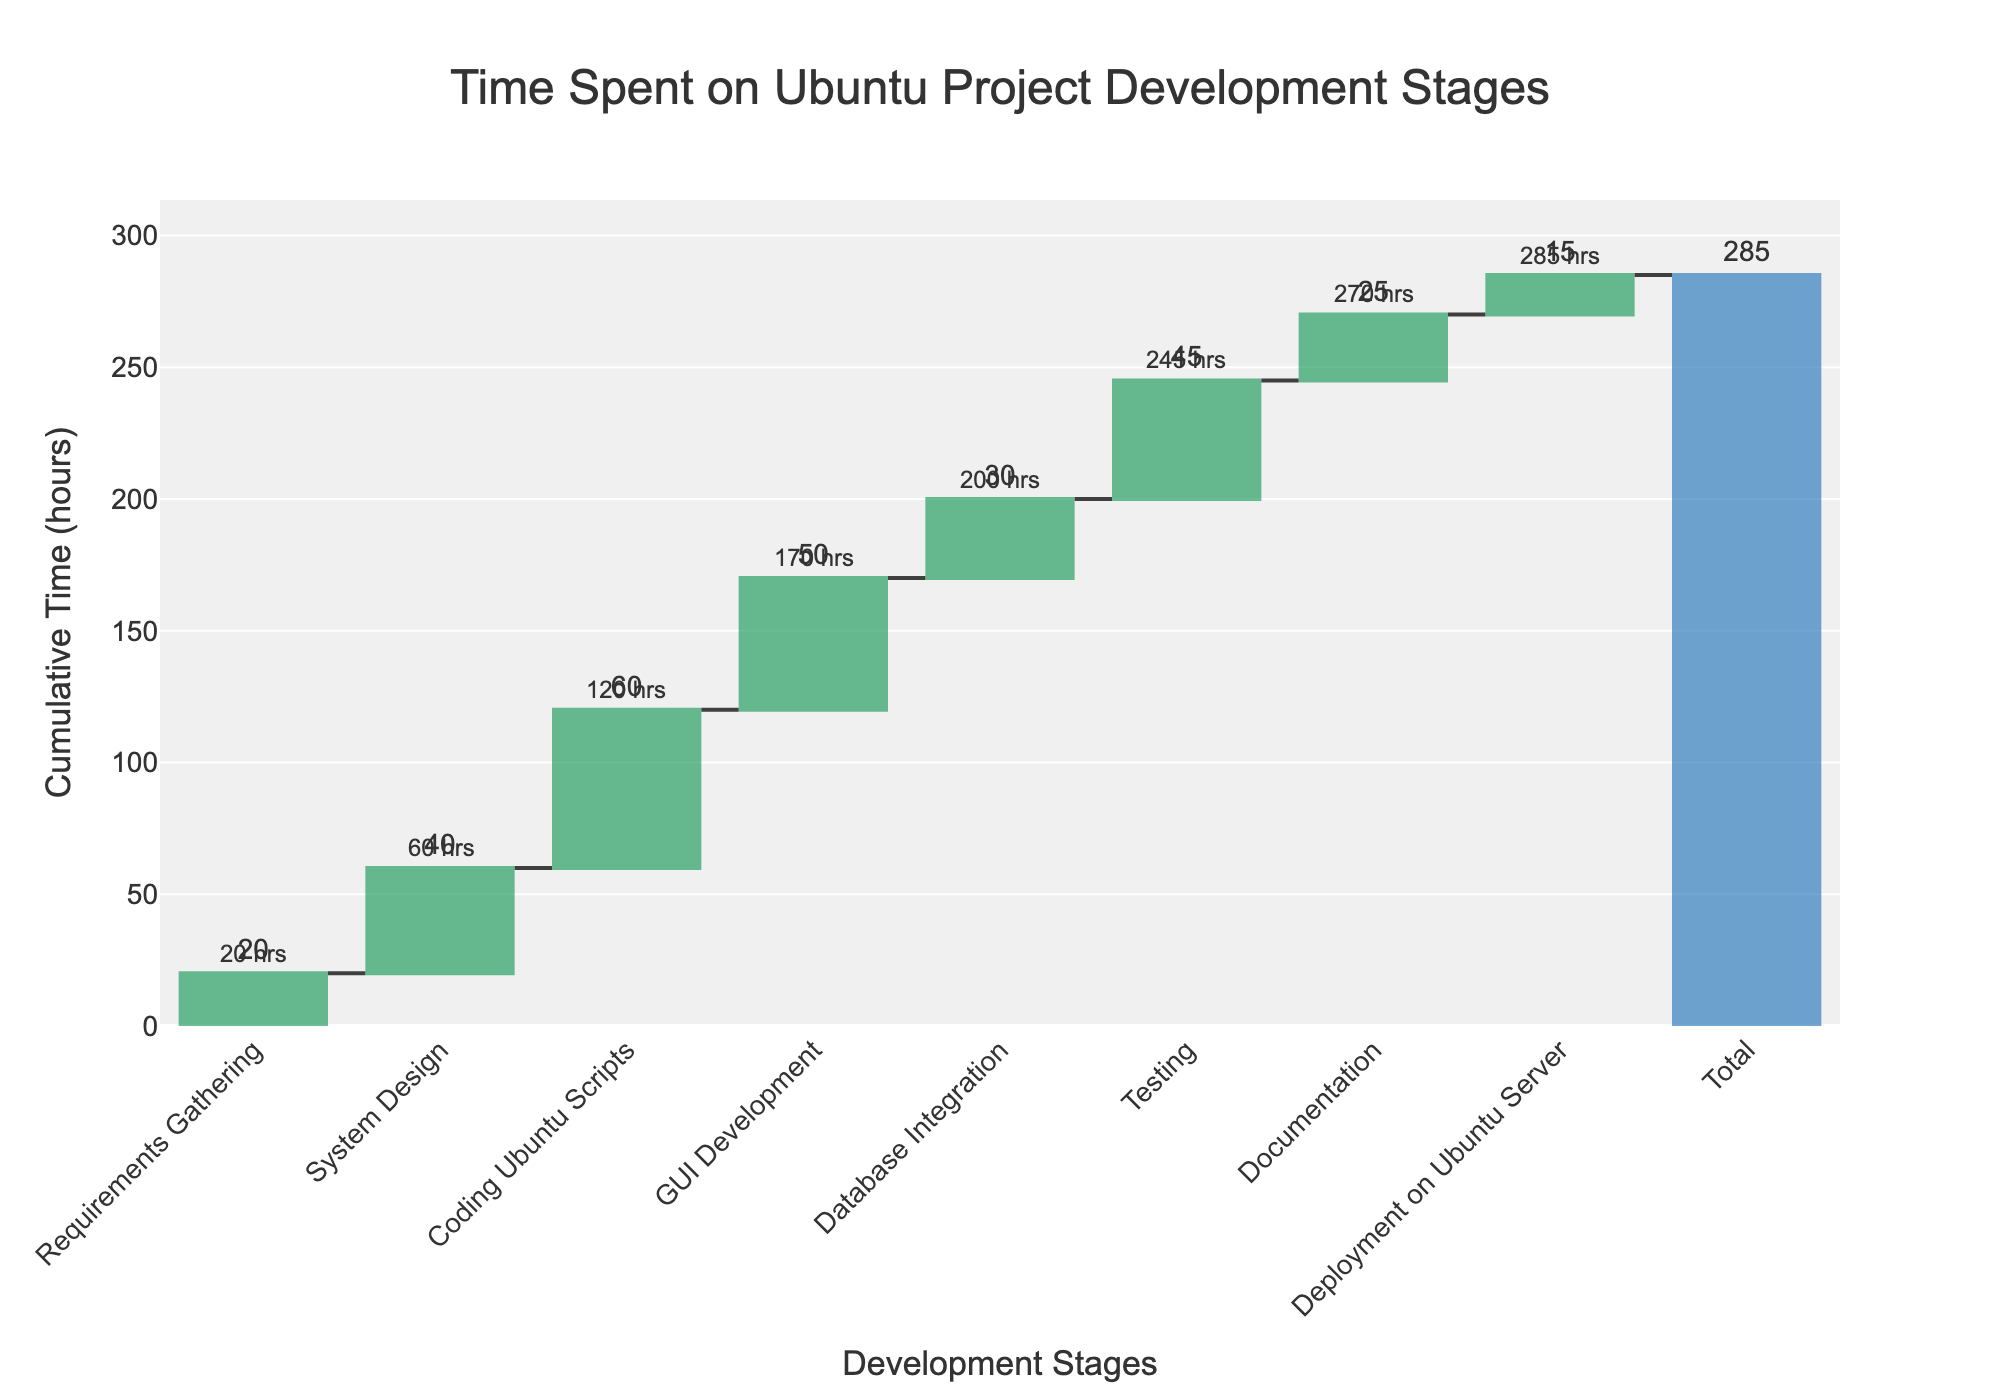What is the title of the chart? The title is displayed at the top of the chart and captures the main topic of the visualization. The title in this chart is "Time Spent on Ubuntu Project Development Stages".
Answer: Time Spent on Ubuntu Project Development Stages How many development stages are there in the chart? By looking at the x-axis, we can count the number of stages (excluding the 'Total' column). There are eight stages listed.
Answer: 8 Which stage has the highest time spent? Visually inspect the height of the bars; the tallest bar indicates the highest time spent. The "Coding Ubuntu Scripts" stage has the highest bar.
Answer: Coding Ubuntu Scripts What is the total cumulative time spent across all stages? The total is displayed as the final bar on the plot. It sums up the time spent across all stages. The "Total" bar shows 285 hours.
Answer: 285 hours What is the cumulative time spent after the "GUI Development" stage? Look at the annotation above the "GUI Development" stage. The cumulative time at this point is 170 hours.
Answer: 170 hours How much more time is spent on "Testing" compared to "Documentation"? Find the bars for "Testing" and "Documentation" and determine their differences in height. Testing has 45 hours, and Documentation has 25 hours. Thus, the difference is 45 - 25 = 20 hours.
Answer: 20 hours What percentage of the total time is spent on "System Design"? The time spent on "System Design" is 40 hours. The total time is 285 hours. Calculate (40 / 285) * 100 to find the percentage. This equals approximately 14.04%.
Answer: 14.04% Which stages have a cumulative time of exactly 50 hours or less? Inspect the annotations to find stages where the cumulative time is 50 hours or less. The stages up to "System Design" meet this condition with cumulative times of 20 and 60 (in sequential exclusion) respectively.
Answer: Requirements Gathering What is the percentage increase in time from "Requirements Gathering" to "Coding Ubuntu Scripts"? Determine the times for "Requirements Gathering" (20 hours) and "Coding Ubuntu Scripts" (60 hours). Calculate the percentage increase: ((60 - 20) / 20) * 100 = 200%.
Answer: 200% How many stages have a time allocation greater than 30 hours? Count the number of bars where the allocated hours exceed 30. The stages are "System Design", "Coding Ubuntu Scripts", "GUI Development", and "Testing". There are four of these stages.
Answer: 4 